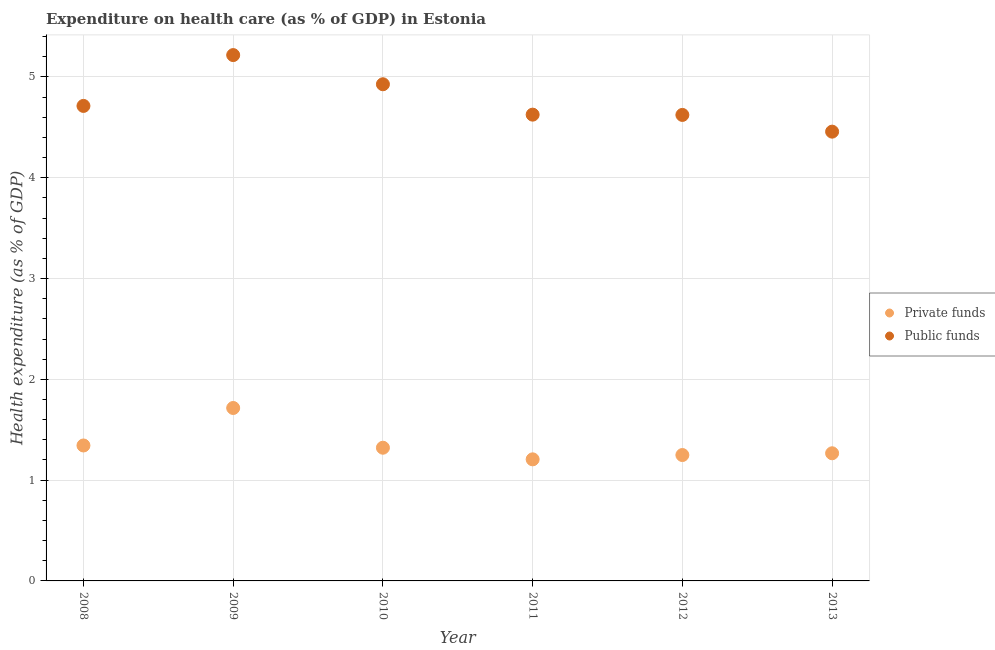How many different coloured dotlines are there?
Provide a succinct answer. 2. Is the number of dotlines equal to the number of legend labels?
Offer a very short reply. Yes. What is the amount of private funds spent in healthcare in 2013?
Make the answer very short. 1.27. Across all years, what is the maximum amount of public funds spent in healthcare?
Offer a terse response. 5.22. Across all years, what is the minimum amount of public funds spent in healthcare?
Your answer should be compact. 4.46. In which year was the amount of public funds spent in healthcare minimum?
Your answer should be very brief. 2013. What is the total amount of private funds spent in healthcare in the graph?
Offer a terse response. 8.1. What is the difference between the amount of private funds spent in healthcare in 2010 and that in 2011?
Ensure brevity in your answer.  0.12. What is the difference between the amount of private funds spent in healthcare in 2011 and the amount of public funds spent in healthcare in 2008?
Offer a terse response. -3.51. What is the average amount of public funds spent in healthcare per year?
Ensure brevity in your answer.  4.76. In the year 2009, what is the difference between the amount of private funds spent in healthcare and amount of public funds spent in healthcare?
Offer a very short reply. -3.5. What is the ratio of the amount of private funds spent in healthcare in 2009 to that in 2010?
Provide a succinct answer. 1.3. Is the difference between the amount of public funds spent in healthcare in 2011 and 2013 greater than the difference between the amount of private funds spent in healthcare in 2011 and 2013?
Provide a succinct answer. Yes. What is the difference between the highest and the second highest amount of private funds spent in healthcare?
Provide a short and direct response. 0.37. What is the difference between the highest and the lowest amount of private funds spent in healthcare?
Provide a succinct answer. 0.51. Is the amount of public funds spent in healthcare strictly greater than the amount of private funds spent in healthcare over the years?
Provide a short and direct response. Yes. Is the amount of public funds spent in healthcare strictly less than the amount of private funds spent in healthcare over the years?
Keep it short and to the point. No. How many dotlines are there?
Give a very brief answer. 2. How many years are there in the graph?
Your answer should be very brief. 6. What is the difference between two consecutive major ticks on the Y-axis?
Your answer should be compact. 1. Does the graph contain any zero values?
Provide a short and direct response. No. Does the graph contain grids?
Offer a very short reply. Yes. Where does the legend appear in the graph?
Offer a terse response. Center right. How many legend labels are there?
Ensure brevity in your answer.  2. What is the title of the graph?
Make the answer very short. Expenditure on health care (as % of GDP) in Estonia. What is the label or title of the Y-axis?
Offer a very short reply. Health expenditure (as % of GDP). What is the Health expenditure (as % of GDP) of Private funds in 2008?
Offer a terse response. 1.34. What is the Health expenditure (as % of GDP) in Public funds in 2008?
Provide a succinct answer. 4.71. What is the Health expenditure (as % of GDP) of Private funds in 2009?
Make the answer very short. 1.72. What is the Health expenditure (as % of GDP) of Public funds in 2009?
Offer a very short reply. 5.22. What is the Health expenditure (as % of GDP) in Private funds in 2010?
Provide a short and direct response. 1.32. What is the Health expenditure (as % of GDP) in Public funds in 2010?
Your answer should be very brief. 4.93. What is the Health expenditure (as % of GDP) of Private funds in 2011?
Your answer should be compact. 1.21. What is the Health expenditure (as % of GDP) in Public funds in 2011?
Keep it short and to the point. 4.63. What is the Health expenditure (as % of GDP) of Private funds in 2012?
Make the answer very short. 1.25. What is the Health expenditure (as % of GDP) in Public funds in 2012?
Your answer should be very brief. 4.62. What is the Health expenditure (as % of GDP) in Private funds in 2013?
Provide a succinct answer. 1.27. What is the Health expenditure (as % of GDP) of Public funds in 2013?
Make the answer very short. 4.46. Across all years, what is the maximum Health expenditure (as % of GDP) in Private funds?
Offer a very short reply. 1.72. Across all years, what is the maximum Health expenditure (as % of GDP) in Public funds?
Your answer should be very brief. 5.22. Across all years, what is the minimum Health expenditure (as % of GDP) of Private funds?
Give a very brief answer. 1.21. Across all years, what is the minimum Health expenditure (as % of GDP) in Public funds?
Your answer should be very brief. 4.46. What is the total Health expenditure (as % of GDP) of Private funds in the graph?
Your answer should be compact. 8.1. What is the total Health expenditure (as % of GDP) of Public funds in the graph?
Ensure brevity in your answer.  28.56. What is the difference between the Health expenditure (as % of GDP) in Private funds in 2008 and that in 2009?
Give a very brief answer. -0.37. What is the difference between the Health expenditure (as % of GDP) of Public funds in 2008 and that in 2009?
Ensure brevity in your answer.  -0.5. What is the difference between the Health expenditure (as % of GDP) of Private funds in 2008 and that in 2010?
Offer a very short reply. 0.02. What is the difference between the Health expenditure (as % of GDP) in Public funds in 2008 and that in 2010?
Your response must be concise. -0.21. What is the difference between the Health expenditure (as % of GDP) of Private funds in 2008 and that in 2011?
Offer a terse response. 0.14. What is the difference between the Health expenditure (as % of GDP) of Public funds in 2008 and that in 2011?
Your answer should be very brief. 0.09. What is the difference between the Health expenditure (as % of GDP) in Private funds in 2008 and that in 2012?
Provide a short and direct response. 0.09. What is the difference between the Health expenditure (as % of GDP) of Public funds in 2008 and that in 2012?
Keep it short and to the point. 0.09. What is the difference between the Health expenditure (as % of GDP) of Private funds in 2008 and that in 2013?
Provide a succinct answer. 0.08. What is the difference between the Health expenditure (as % of GDP) in Public funds in 2008 and that in 2013?
Offer a terse response. 0.26. What is the difference between the Health expenditure (as % of GDP) of Private funds in 2009 and that in 2010?
Make the answer very short. 0.39. What is the difference between the Health expenditure (as % of GDP) of Public funds in 2009 and that in 2010?
Offer a terse response. 0.29. What is the difference between the Health expenditure (as % of GDP) of Private funds in 2009 and that in 2011?
Offer a very short reply. 0.51. What is the difference between the Health expenditure (as % of GDP) of Public funds in 2009 and that in 2011?
Offer a very short reply. 0.59. What is the difference between the Health expenditure (as % of GDP) in Private funds in 2009 and that in 2012?
Give a very brief answer. 0.47. What is the difference between the Health expenditure (as % of GDP) in Public funds in 2009 and that in 2012?
Make the answer very short. 0.59. What is the difference between the Health expenditure (as % of GDP) of Private funds in 2009 and that in 2013?
Your answer should be very brief. 0.45. What is the difference between the Health expenditure (as % of GDP) in Public funds in 2009 and that in 2013?
Make the answer very short. 0.76. What is the difference between the Health expenditure (as % of GDP) of Private funds in 2010 and that in 2011?
Ensure brevity in your answer.  0.12. What is the difference between the Health expenditure (as % of GDP) in Public funds in 2010 and that in 2011?
Make the answer very short. 0.3. What is the difference between the Health expenditure (as % of GDP) in Private funds in 2010 and that in 2012?
Your answer should be compact. 0.07. What is the difference between the Health expenditure (as % of GDP) in Public funds in 2010 and that in 2012?
Keep it short and to the point. 0.3. What is the difference between the Health expenditure (as % of GDP) in Private funds in 2010 and that in 2013?
Your answer should be very brief. 0.06. What is the difference between the Health expenditure (as % of GDP) of Public funds in 2010 and that in 2013?
Ensure brevity in your answer.  0.47. What is the difference between the Health expenditure (as % of GDP) in Private funds in 2011 and that in 2012?
Your answer should be compact. -0.04. What is the difference between the Health expenditure (as % of GDP) in Public funds in 2011 and that in 2012?
Offer a very short reply. 0. What is the difference between the Health expenditure (as % of GDP) of Private funds in 2011 and that in 2013?
Give a very brief answer. -0.06. What is the difference between the Health expenditure (as % of GDP) in Public funds in 2011 and that in 2013?
Keep it short and to the point. 0.17. What is the difference between the Health expenditure (as % of GDP) in Private funds in 2012 and that in 2013?
Your response must be concise. -0.02. What is the difference between the Health expenditure (as % of GDP) in Public funds in 2012 and that in 2013?
Give a very brief answer. 0.17. What is the difference between the Health expenditure (as % of GDP) in Private funds in 2008 and the Health expenditure (as % of GDP) in Public funds in 2009?
Offer a very short reply. -3.87. What is the difference between the Health expenditure (as % of GDP) in Private funds in 2008 and the Health expenditure (as % of GDP) in Public funds in 2010?
Keep it short and to the point. -3.58. What is the difference between the Health expenditure (as % of GDP) of Private funds in 2008 and the Health expenditure (as % of GDP) of Public funds in 2011?
Give a very brief answer. -3.28. What is the difference between the Health expenditure (as % of GDP) in Private funds in 2008 and the Health expenditure (as % of GDP) in Public funds in 2012?
Offer a terse response. -3.28. What is the difference between the Health expenditure (as % of GDP) of Private funds in 2008 and the Health expenditure (as % of GDP) of Public funds in 2013?
Make the answer very short. -3.11. What is the difference between the Health expenditure (as % of GDP) in Private funds in 2009 and the Health expenditure (as % of GDP) in Public funds in 2010?
Give a very brief answer. -3.21. What is the difference between the Health expenditure (as % of GDP) in Private funds in 2009 and the Health expenditure (as % of GDP) in Public funds in 2011?
Make the answer very short. -2.91. What is the difference between the Health expenditure (as % of GDP) of Private funds in 2009 and the Health expenditure (as % of GDP) of Public funds in 2012?
Offer a terse response. -2.91. What is the difference between the Health expenditure (as % of GDP) in Private funds in 2009 and the Health expenditure (as % of GDP) in Public funds in 2013?
Keep it short and to the point. -2.74. What is the difference between the Health expenditure (as % of GDP) in Private funds in 2010 and the Health expenditure (as % of GDP) in Public funds in 2011?
Your answer should be very brief. -3.3. What is the difference between the Health expenditure (as % of GDP) of Private funds in 2010 and the Health expenditure (as % of GDP) of Public funds in 2012?
Provide a short and direct response. -3.3. What is the difference between the Health expenditure (as % of GDP) of Private funds in 2010 and the Health expenditure (as % of GDP) of Public funds in 2013?
Make the answer very short. -3.14. What is the difference between the Health expenditure (as % of GDP) of Private funds in 2011 and the Health expenditure (as % of GDP) of Public funds in 2012?
Give a very brief answer. -3.42. What is the difference between the Health expenditure (as % of GDP) of Private funds in 2011 and the Health expenditure (as % of GDP) of Public funds in 2013?
Provide a succinct answer. -3.25. What is the difference between the Health expenditure (as % of GDP) of Private funds in 2012 and the Health expenditure (as % of GDP) of Public funds in 2013?
Your response must be concise. -3.21. What is the average Health expenditure (as % of GDP) in Private funds per year?
Make the answer very short. 1.35. What is the average Health expenditure (as % of GDP) of Public funds per year?
Offer a terse response. 4.76. In the year 2008, what is the difference between the Health expenditure (as % of GDP) of Private funds and Health expenditure (as % of GDP) of Public funds?
Offer a very short reply. -3.37. In the year 2009, what is the difference between the Health expenditure (as % of GDP) of Private funds and Health expenditure (as % of GDP) of Public funds?
Offer a terse response. -3.5. In the year 2010, what is the difference between the Health expenditure (as % of GDP) of Private funds and Health expenditure (as % of GDP) of Public funds?
Offer a terse response. -3.61. In the year 2011, what is the difference between the Health expenditure (as % of GDP) in Private funds and Health expenditure (as % of GDP) in Public funds?
Give a very brief answer. -3.42. In the year 2012, what is the difference between the Health expenditure (as % of GDP) of Private funds and Health expenditure (as % of GDP) of Public funds?
Provide a succinct answer. -3.37. In the year 2013, what is the difference between the Health expenditure (as % of GDP) in Private funds and Health expenditure (as % of GDP) in Public funds?
Your response must be concise. -3.19. What is the ratio of the Health expenditure (as % of GDP) in Private funds in 2008 to that in 2009?
Offer a terse response. 0.78. What is the ratio of the Health expenditure (as % of GDP) in Public funds in 2008 to that in 2009?
Offer a terse response. 0.9. What is the ratio of the Health expenditure (as % of GDP) of Private funds in 2008 to that in 2010?
Provide a succinct answer. 1.02. What is the ratio of the Health expenditure (as % of GDP) in Public funds in 2008 to that in 2010?
Provide a succinct answer. 0.96. What is the ratio of the Health expenditure (as % of GDP) of Private funds in 2008 to that in 2011?
Make the answer very short. 1.11. What is the ratio of the Health expenditure (as % of GDP) of Public funds in 2008 to that in 2011?
Ensure brevity in your answer.  1.02. What is the ratio of the Health expenditure (as % of GDP) in Private funds in 2008 to that in 2012?
Provide a short and direct response. 1.08. What is the ratio of the Health expenditure (as % of GDP) of Public funds in 2008 to that in 2012?
Offer a very short reply. 1.02. What is the ratio of the Health expenditure (as % of GDP) of Private funds in 2008 to that in 2013?
Offer a very short reply. 1.06. What is the ratio of the Health expenditure (as % of GDP) in Public funds in 2008 to that in 2013?
Your response must be concise. 1.06. What is the ratio of the Health expenditure (as % of GDP) of Private funds in 2009 to that in 2010?
Your answer should be very brief. 1.3. What is the ratio of the Health expenditure (as % of GDP) in Public funds in 2009 to that in 2010?
Your answer should be compact. 1.06. What is the ratio of the Health expenditure (as % of GDP) of Private funds in 2009 to that in 2011?
Make the answer very short. 1.42. What is the ratio of the Health expenditure (as % of GDP) of Public funds in 2009 to that in 2011?
Your response must be concise. 1.13. What is the ratio of the Health expenditure (as % of GDP) in Private funds in 2009 to that in 2012?
Keep it short and to the point. 1.37. What is the ratio of the Health expenditure (as % of GDP) in Public funds in 2009 to that in 2012?
Offer a terse response. 1.13. What is the ratio of the Health expenditure (as % of GDP) of Private funds in 2009 to that in 2013?
Ensure brevity in your answer.  1.35. What is the ratio of the Health expenditure (as % of GDP) in Public funds in 2009 to that in 2013?
Give a very brief answer. 1.17. What is the ratio of the Health expenditure (as % of GDP) in Private funds in 2010 to that in 2011?
Your answer should be compact. 1.1. What is the ratio of the Health expenditure (as % of GDP) of Public funds in 2010 to that in 2011?
Your response must be concise. 1.07. What is the ratio of the Health expenditure (as % of GDP) of Private funds in 2010 to that in 2012?
Offer a terse response. 1.06. What is the ratio of the Health expenditure (as % of GDP) of Public funds in 2010 to that in 2012?
Your answer should be very brief. 1.07. What is the ratio of the Health expenditure (as % of GDP) of Private funds in 2010 to that in 2013?
Offer a very short reply. 1.04. What is the ratio of the Health expenditure (as % of GDP) in Public funds in 2010 to that in 2013?
Keep it short and to the point. 1.11. What is the ratio of the Health expenditure (as % of GDP) in Private funds in 2011 to that in 2012?
Your response must be concise. 0.97. What is the ratio of the Health expenditure (as % of GDP) in Public funds in 2011 to that in 2012?
Ensure brevity in your answer.  1. What is the ratio of the Health expenditure (as % of GDP) in Private funds in 2011 to that in 2013?
Keep it short and to the point. 0.95. What is the ratio of the Health expenditure (as % of GDP) of Public funds in 2011 to that in 2013?
Ensure brevity in your answer.  1.04. What is the ratio of the Health expenditure (as % of GDP) of Private funds in 2012 to that in 2013?
Your answer should be compact. 0.99. What is the ratio of the Health expenditure (as % of GDP) of Public funds in 2012 to that in 2013?
Keep it short and to the point. 1.04. What is the difference between the highest and the second highest Health expenditure (as % of GDP) of Private funds?
Make the answer very short. 0.37. What is the difference between the highest and the second highest Health expenditure (as % of GDP) in Public funds?
Ensure brevity in your answer.  0.29. What is the difference between the highest and the lowest Health expenditure (as % of GDP) of Private funds?
Offer a terse response. 0.51. What is the difference between the highest and the lowest Health expenditure (as % of GDP) in Public funds?
Provide a succinct answer. 0.76. 